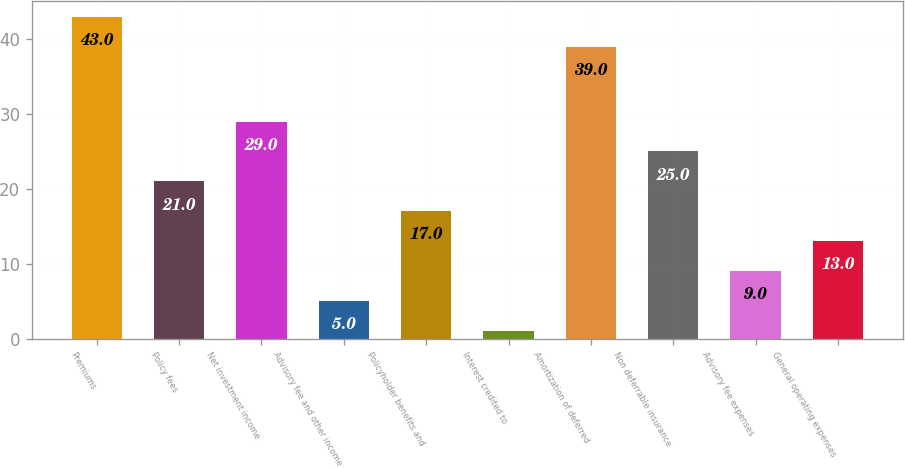Convert chart to OTSL. <chart><loc_0><loc_0><loc_500><loc_500><bar_chart><fcel>Premiums<fcel>Policy fees<fcel>Net investment income<fcel>Advisory fee and other income<fcel>Policyholder benefits and<fcel>Interest credited to<fcel>Amortization of deferred<fcel>Non deferrable insurance<fcel>Advisory fee expenses<fcel>General operating expenses<nl><fcel>43<fcel>21<fcel>29<fcel>5<fcel>17<fcel>1<fcel>39<fcel>25<fcel>9<fcel>13<nl></chart> 